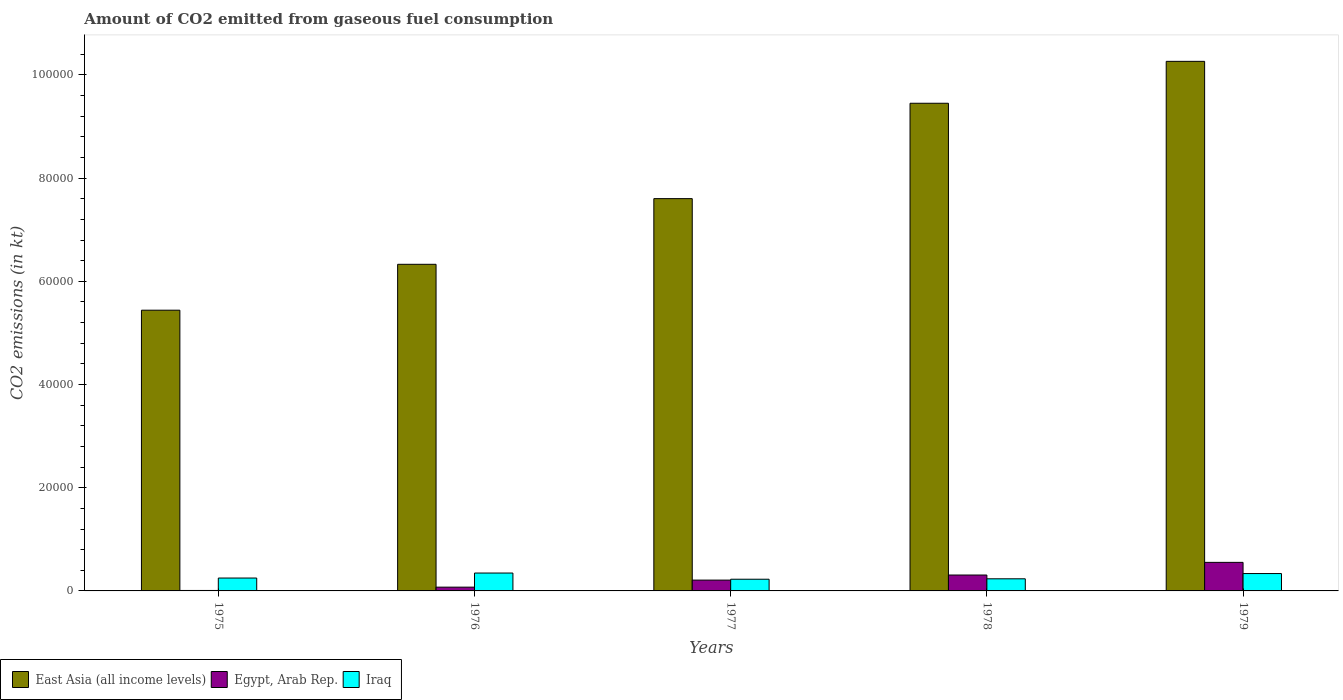Are the number of bars per tick equal to the number of legend labels?
Your response must be concise. Yes. Are the number of bars on each tick of the X-axis equal?
Provide a succinct answer. Yes. What is the label of the 1st group of bars from the left?
Your response must be concise. 1975. In how many cases, is the number of bars for a given year not equal to the number of legend labels?
Your response must be concise. 0. What is the amount of CO2 emitted in East Asia (all income levels) in 1976?
Ensure brevity in your answer.  6.33e+04. Across all years, what is the maximum amount of CO2 emitted in East Asia (all income levels)?
Provide a succinct answer. 1.03e+05. Across all years, what is the minimum amount of CO2 emitted in Egypt, Arab Rep.?
Your answer should be very brief. 88.01. In which year was the amount of CO2 emitted in Iraq maximum?
Your answer should be very brief. 1976. In which year was the amount of CO2 emitted in East Asia (all income levels) minimum?
Give a very brief answer. 1975. What is the total amount of CO2 emitted in East Asia (all income levels) in the graph?
Give a very brief answer. 3.91e+05. What is the difference between the amount of CO2 emitted in East Asia (all income levels) in 1976 and that in 1977?
Your answer should be very brief. -1.27e+04. What is the difference between the amount of CO2 emitted in Iraq in 1977 and the amount of CO2 emitted in East Asia (all income levels) in 1976?
Provide a succinct answer. -6.10e+04. What is the average amount of CO2 emitted in Egypt, Arab Rep. per year?
Keep it short and to the point. 2305.81. In the year 1977, what is the difference between the amount of CO2 emitted in Iraq and amount of CO2 emitted in East Asia (all income levels)?
Your answer should be very brief. -7.38e+04. What is the ratio of the amount of CO2 emitted in East Asia (all income levels) in 1975 to that in 1976?
Offer a very short reply. 0.86. Is the amount of CO2 emitted in Egypt, Arab Rep. in 1976 less than that in 1977?
Offer a very short reply. Yes. Is the difference between the amount of CO2 emitted in Iraq in 1975 and 1978 greater than the difference between the amount of CO2 emitted in East Asia (all income levels) in 1975 and 1978?
Provide a succinct answer. Yes. What is the difference between the highest and the second highest amount of CO2 emitted in Egypt, Arab Rep.?
Your answer should be very brief. 2453.22. What is the difference between the highest and the lowest amount of CO2 emitted in East Asia (all income levels)?
Your answer should be very brief. 4.82e+04. Is the sum of the amount of CO2 emitted in East Asia (all income levels) in 1975 and 1978 greater than the maximum amount of CO2 emitted in Egypt, Arab Rep. across all years?
Your response must be concise. Yes. What does the 3rd bar from the left in 1975 represents?
Offer a terse response. Iraq. What does the 2nd bar from the right in 1978 represents?
Give a very brief answer. Egypt, Arab Rep. Are the values on the major ticks of Y-axis written in scientific E-notation?
Provide a succinct answer. No. Does the graph contain any zero values?
Keep it short and to the point. No. Does the graph contain grids?
Provide a short and direct response. No. How many legend labels are there?
Make the answer very short. 3. What is the title of the graph?
Your answer should be very brief. Amount of CO2 emitted from gaseous fuel consumption. What is the label or title of the X-axis?
Ensure brevity in your answer.  Years. What is the label or title of the Y-axis?
Give a very brief answer. CO2 emissions (in kt). What is the CO2 emissions (in kt) in East Asia (all income levels) in 1975?
Offer a very short reply. 5.44e+04. What is the CO2 emissions (in kt) in Egypt, Arab Rep. in 1975?
Your response must be concise. 88.01. What is the CO2 emissions (in kt) in Iraq in 1975?
Offer a very short reply. 2497.23. What is the CO2 emissions (in kt) in East Asia (all income levels) in 1976?
Your answer should be very brief. 6.33e+04. What is the CO2 emissions (in kt) in Egypt, Arab Rep. in 1976?
Offer a terse response. 729.73. What is the CO2 emissions (in kt) of Iraq in 1976?
Keep it short and to the point. 3465.32. What is the CO2 emissions (in kt) in East Asia (all income levels) in 1977?
Your answer should be compact. 7.60e+04. What is the CO2 emissions (in kt) of Egypt, Arab Rep. in 1977?
Provide a short and direct response. 2097.52. What is the CO2 emissions (in kt) in Iraq in 1977?
Provide a succinct answer. 2266.21. What is the CO2 emissions (in kt) in East Asia (all income levels) in 1978?
Give a very brief answer. 9.45e+04. What is the CO2 emissions (in kt) of Egypt, Arab Rep. in 1978?
Offer a terse response. 3080.28. What is the CO2 emissions (in kt) of Iraq in 1978?
Offer a very short reply. 2346.88. What is the CO2 emissions (in kt) in East Asia (all income levels) in 1979?
Your response must be concise. 1.03e+05. What is the CO2 emissions (in kt) in Egypt, Arab Rep. in 1979?
Your response must be concise. 5533.5. What is the CO2 emissions (in kt) of Iraq in 1979?
Ensure brevity in your answer.  3366.31. Across all years, what is the maximum CO2 emissions (in kt) in East Asia (all income levels)?
Your answer should be compact. 1.03e+05. Across all years, what is the maximum CO2 emissions (in kt) of Egypt, Arab Rep.?
Provide a succinct answer. 5533.5. Across all years, what is the maximum CO2 emissions (in kt) of Iraq?
Your response must be concise. 3465.32. Across all years, what is the minimum CO2 emissions (in kt) in East Asia (all income levels)?
Provide a short and direct response. 5.44e+04. Across all years, what is the minimum CO2 emissions (in kt) in Egypt, Arab Rep.?
Provide a short and direct response. 88.01. Across all years, what is the minimum CO2 emissions (in kt) of Iraq?
Keep it short and to the point. 2266.21. What is the total CO2 emissions (in kt) of East Asia (all income levels) in the graph?
Offer a terse response. 3.91e+05. What is the total CO2 emissions (in kt) of Egypt, Arab Rep. in the graph?
Ensure brevity in your answer.  1.15e+04. What is the total CO2 emissions (in kt) in Iraq in the graph?
Your response must be concise. 1.39e+04. What is the difference between the CO2 emissions (in kt) of East Asia (all income levels) in 1975 and that in 1976?
Offer a very short reply. -8892.04. What is the difference between the CO2 emissions (in kt) of Egypt, Arab Rep. in 1975 and that in 1976?
Your answer should be very brief. -641.73. What is the difference between the CO2 emissions (in kt) in Iraq in 1975 and that in 1976?
Your response must be concise. -968.09. What is the difference between the CO2 emissions (in kt) of East Asia (all income levels) in 1975 and that in 1977?
Provide a succinct answer. -2.16e+04. What is the difference between the CO2 emissions (in kt) of Egypt, Arab Rep. in 1975 and that in 1977?
Provide a succinct answer. -2009.52. What is the difference between the CO2 emissions (in kt) of Iraq in 1975 and that in 1977?
Offer a very short reply. 231.02. What is the difference between the CO2 emissions (in kt) of East Asia (all income levels) in 1975 and that in 1978?
Your answer should be compact. -4.01e+04. What is the difference between the CO2 emissions (in kt) in Egypt, Arab Rep. in 1975 and that in 1978?
Offer a very short reply. -2992.27. What is the difference between the CO2 emissions (in kt) of Iraq in 1975 and that in 1978?
Your response must be concise. 150.35. What is the difference between the CO2 emissions (in kt) in East Asia (all income levels) in 1975 and that in 1979?
Give a very brief answer. -4.82e+04. What is the difference between the CO2 emissions (in kt) of Egypt, Arab Rep. in 1975 and that in 1979?
Make the answer very short. -5445.49. What is the difference between the CO2 emissions (in kt) in Iraq in 1975 and that in 1979?
Ensure brevity in your answer.  -869.08. What is the difference between the CO2 emissions (in kt) in East Asia (all income levels) in 1976 and that in 1977?
Ensure brevity in your answer.  -1.27e+04. What is the difference between the CO2 emissions (in kt) of Egypt, Arab Rep. in 1976 and that in 1977?
Your answer should be compact. -1367.79. What is the difference between the CO2 emissions (in kt) of Iraq in 1976 and that in 1977?
Provide a succinct answer. 1199.11. What is the difference between the CO2 emissions (in kt) of East Asia (all income levels) in 1976 and that in 1978?
Ensure brevity in your answer.  -3.12e+04. What is the difference between the CO2 emissions (in kt) in Egypt, Arab Rep. in 1976 and that in 1978?
Make the answer very short. -2350.55. What is the difference between the CO2 emissions (in kt) in Iraq in 1976 and that in 1978?
Provide a short and direct response. 1118.43. What is the difference between the CO2 emissions (in kt) in East Asia (all income levels) in 1976 and that in 1979?
Ensure brevity in your answer.  -3.93e+04. What is the difference between the CO2 emissions (in kt) in Egypt, Arab Rep. in 1976 and that in 1979?
Make the answer very short. -4803.77. What is the difference between the CO2 emissions (in kt) in Iraq in 1976 and that in 1979?
Offer a terse response. 99.01. What is the difference between the CO2 emissions (in kt) in East Asia (all income levels) in 1977 and that in 1978?
Make the answer very short. -1.85e+04. What is the difference between the CO2 emissions (in kt) in Egypt, Arab Rep. in 1977 and that in 1978?
Make the answer very short. -982.76. What is the difference between the CO2 emissions (in kt) of Iraq in 1977 and that in 1978?
Ensure brevity in your answer.  -80.67. What is the difference between the CO2 emissions (in kt) of East Asia (all income levels) in 1977 and that in 1979?
Offer a terse response. -2.66e+04. What is the difference between the CO2 emissions (in kt) of Egypt, Arab Rep. in 1977 and that in 1979?
Your answer should be compact. -3435.98. What is the difference between the CO2 emissions (in kt) in Iraq in 1977 and that in 1979?
Provide a short and direct response. -1100.1. What is the difference between the CO2 emissions (in kt) of East Asia (all income levels) in 1978 and that in 1979?
Give a very brief answer. -8120.28. What is the difference between the CO2 emissions (in kt) of Egypt, Arab Rep. in 1978 and that in 1979?
Provide a short and direct response. -2453.22. What is the difference between the CO2 emissions (in kt) of Iraq in 1978 and that in 1979?
Offer a very short reply. -1019.43. What is the difference between the CO2 emissions (in kt) of East Asia (all income levels) in 1975 and the CO2 emissions (in kt) of Egypt, Arab Rep. in 1976?
Ensure brevity in your answer.  5.37e+04. What is the difference between the CO2 emissions (in kt) in East Asia (all income levels) in 1975 and the CO2 emissions (in kt) in Iraq in 1976?
Ensure brevity in your answer.  5.09e+04. What is the difference between the CO2 emissions (in kt) in Egypt, Arab Rep. in 1975 and the CO2 emissions (in kt) in Iraq in 1976?
Keep it short and to the point. -3377.31. What is the difference between the CO2 emissions (in kt) in East Asia (all income levels) in 1975 and the CO2 emissions (in kt) in Egypt, Arab Rep. in 1977?
Ensure brevity in your answer.  5.23e+04. What is the difference between the CO2 emissions (in kt) of East Asia (all income levels) in 1975 and the CO2 emissions (in kt) of Iraq in 1977?
Offer a terse response. 5.21e+04. What is the difference between the CO2 emissions (in kt) of Egypt, Arab Rep. in 1975 and the CO2 emissions (in kt) of Iraq in 1977?
Your answer should be compact. -2178.2. What is the difference between the CO2 emissions (in kt) in East Asia (all income levels) in 1975 and the CO2 emissions (in kt) in Egypt, Arab Rep. in 1978?
Give a very brief answer. 5.13e+04. What is the difference between the CO2 emissions (in kt) of East Asia (all income levels) in 1975 and the CO2 emissions (in kt) of Iraq in 1978?
Your answer should be very brief. 5.21e+04. What is the difference between the CO2 emissions (in kt) in Egypt, Arab Rep. in 1975 and the CO2 emissions (in kt) in Iraq in 1978?
Your response must be concise. -2258.87. What is the difference between the CO2 emissions (in kt) in East Asia (all income levels) in 1975 and the CO2 emissions (in kt) in Egypt, Arab Rep. in 1979?
Your answer should be compact. 4.89e+04. What is the difference between the CO2 emissions (in kt) of East Asia (all income levels) in 1975 and the CO2 emissions (in kt) of Iraq in 1979?
Offer a very short reply. 5.10e+04. What is the difference between the CO2 emissions (in kt) of Egypt, Arab Rep. in 1975 and the CO2 emissions (in kt) of Iraq in 1979?
Ensure brevity in your answer.  -3278.3. What is the difference between the CO2 emissions (in kt) in East Asia (all income levels) in 1976 and the CO2 emissions (in kt) in Egypt, Arab Rep. in 1977?
Provide a succinct answer. 6.12e+04. What is the difference between the CO2 emissions (in kt) in East Asia (all income levels) in 1976 and the CO2 emissions (in kt) in Iraq in 1977?
Offer a terse response. 6.10e+04. What is the difference between the CO2 emissions (in kt) of Egypt, Arab Rep. in 1976 and the CO2 emissions (in kt) of Iraq in 1977?
Provide a short and direct response. -1536.47. What is the difference between the CO2 emissions (in kt) in East Asia (all income levels) in 1976 and the CO2 emissions (in kt) in Egypt, Arab Rep. in 1978?
Make the answer very short. 6.02e+04. What is the difference between the CO2 emissions (in kt) in East Asia (all income levels) in 1976 and the CO2 emissions (in kt) in Iraq in 1978?
Provide a short and direct response. 6.10e+04. What is the difference between the CO2 emissions (in kt) in Egypt, Arab Rep. in 1976 and the CO2 emissions (in kt) in Iraq in 1978?
Keep it short and to the point. -1617.15. What is the difference between the CO2 emissions (in kt) of East Asia (all income levels) in 1976 and the CO2 emissions (in kt) of Egypt, Arab Rep. in 1979?
Provide a short and direct response. 5.78e+04. What is the difference between the CO2 emissions (in kt) in East Asia (all income levels) in 1976 and the CO2 emissions (in kt) in Iraq in 1979?
Provide a succinct answer. 5.99e+04. What is the difference between the CO2 emissions (in kt) in Egypt, Arab Rep. in 1976 and the CO2 emissions (in kt) in Iraq in 1979?
Provide a short and direct response. -2636.57. What is the difference between the CO2 emissions (in kt) of East Asia (all income levels) in 1977 and the CO2 emissions (in kt) of Egypt, Arab Rep. in 1978?
Offer a terse response. 7.29e+04. What is the difference between the CO2 emissions (in kt) in East Asia (all income levels) in 1977 and the CO2 emissions (in kt) in Iraq in 1978?
Your answer should be compact. 7.37e+04. What is the difference between the CO2 emissions (in kt) of Egypt, Arab Rep. in 1977 and the CO2 emissions (in kt) of Iraq in 1978?
Offer a very short reply. -249.36. What is the difference between the CO2 emissions (in kt) in East Asia (all income levels) in 1977 and the CO2 emissions (in kt) in Egypt, Arab Rep. in 1979?
Provide a succinct answer. 7.05e+04. What is the difference between the CO2 emissions (in kt) in East Asia (all income levels) in 1977 and the CO2 emissions (in kt) in Iraq in 1979?
Provide a short and direct response. 7.27e+04. What is the difference between the CO2 emissions (in kt) in Egypt, Arab Rep. in 1977 and the CO2 emissions (in kt) in Iraq in 1979?
Offer a terse response. -1268.78. What is the difference between the CO2 emissions (in kt) of East Asia (all income levels) in 1978 and the CO2 emissions (in kt) of Egypt, Arab Rep. in 1979?
Make the answer very short. 8.90e+04. What is the difference between the CO2 emissions (in kt) in East Asia (all income levels) in 1978 and the CO2 emissions (in kt) in Iraq in 1979?
Offer a very short reply. 9.11e+04. What is the difference between the CO2 emissions (in kt) in Egypt, Arab Rep. in 1978 and the CO2 emissions (in kt) in Iraq in 1979?
Give a very brief answer. -286.03. What is the average CO2 emissions (in kt) in East Asia (all income levels) per year?
Provide a short and direct response. 7.82e+04. What is the average CO2 emissions (in kt) in Egypt, Arab Rep. per year?
Offer a very short reply. 2305.81. What is the average CO2 emissions (in kt) of Iraq per year?
Your answer should be compact. 2788.39. In the year 1975, what is the difference between the CO2 emissions (in kt) in East Asia (all income levels) and CO2 emissions (in kt) in Egypt, Arab Rep.?
Your answer should be compact. 5.43e+04. In the year 1975, what is the difference between the CO2 emissions (in kt) in East Asia (all income levels) and CO2 emissions (in kt) in Iraq?
Provide a short and direct response. 5.19e+04. In the year 1975, what is the difference between the CO2 emissions (in kt) in Egypt, Arab Rep. and CO2 emissions (in kt) in Iraq?
Provide a succinct answer. -2409.22. In the year 1976, what is the difference between the CO2 emissions (in kt) in East Asia (all income levels) and CO2 emissions (in kt) in Egypt, Arab Rep.?
Provide a short and direct response. 6.26e+04. In the year 1976, what is the difference between the CO2 emissions (in kt) in East Asia (all income levels) and CO2 emissions (in kt) in Iraq?
Give a very brief answer. 5.98e+04. In the year 1976, what is the difference between the CO2 emissions (in kt) in Egypt, Arab Rep. and CO2 emissions (in kt) in Iraq?
Your response must be concise. -2735.58. In the year 1977, what is the difference between the CO2 emissions (in kt) in East Asia (all income levels) and CO2 emissions (in kt) in Egypt, Arab Rep.?
Ensure brevity in your answer.  7.39e+04. In the year 1977, what is the difference between the CO2 emissions (in kt) of East Asia (all income levels) and CO2 emissions (in kt) of Iraq?
Provide a succinct answer. 7.38e+04. In the year 1977, what is the difference between the CO2 emissions (in kt) in Egypt, Arab Rep. and CO2 emissions (in kt) in Iraq?
Offer a terse response. -168.68. In the year 1978, what is the difference between the CO2 emissions (in kt) of East Asia (all income levels) and CO2 emissions (in kt) of Egypt, Arab Rep.?
Provide a short and direct response. 9.14e+04. In the year 1978, what is the difference between the CO2 emissions (in kt) of East Asia (all income levels) and CO2 emissions (in kt) of Iraq?
Offer a very short reply. 9.22e+04. In the year 1978, what is the difference between the CO2 emissions (in kt) of Egypt, Arab Rep. and CO2 emissions (in kt) of Iraq?
Your response must be concise. 733.4. In the year 1979, what is the difference between the CO2 emissions (in kt) in East Asia (all income levels) and CO2 emissions (in kt) in Egypt, Arab Rep.?
Provide a succinct answer. 9.71e+04. In the year 1979, what is the difference between the CO2 emissions (in kt) in East Asia (all income levels) and CO2 emissions (in kt) in Iraq?
Your response must be concise. 9.93e+04. In the year 1979, what is the difference between the CO2 emissions (in kt) of Egypt, Arab Rep. and CO2 emissions (in kt) of Iraq?
Offer a very short reply. 2167.2. What is the ratio of the CO2 emissions (in kt) in East Asia (all income levels) in 1975 to that in 1976?
Keep it short and to the point. 0.86. What is the ratio of the CO2 emissions (in kt) of Egypt, Arab Rep. in 1975 to that in 1976?
Keep it short and to the point. 0.12. What is the ratio of the CO2 emissions (in kt) of Iraq in 1975 to that in 1976?
Your response must be concise. 0.72. What is the ratio of the CO2 emissions (in kt) in East Asia (all income levels) in 1975 to that in 1977?
Offer a very short reply. 0.72. What is the ratio of the CO2 emissions (in kt) of Egypt, Arab Rep. in 1975 to that in 1977?
Your answer should be compact. 0.04. What is the ratio of the CO2 emissions (in kt) of Iraq in 1975 to that in 1977?
Your answer should be very brief. 1.1. What is the ratio of the CO2 emissions (in kt) in East Asia (all income levels) in 1975 to that in 1978?
Ensure brevity in your answer.  0.58. What is the ratio of the CO2 emissions (in kt) of Egypt, Arab Rep. in 1975 to that in 1978?
Make the answer very short. 0.03. What is the ratio of the CO2 emissions (in kt) of Iraq in 1975 to that in 1978?
Make the answer very short. 1.06. What is the ratio of the CO2 emissions (in kt) of East Asia (all income levels) in 1975 to that in 1979?
Ensure brevity in your answer.  0.53. What is the ratio of the CO2 emissions (in kt) in Egypt, Arab Rep. in 1975 to that in 1979?
Keep it short and to the point. 0.02. What is the ratio of the CO2 emissions (in kt) of Iraq in 1975 to that in 1979?
Keep it short and to the point. 0.74. What is the ratio of the CO2 emissions (in kt) in East Asia (all income levels) in 1976 to that in 1977?
Provide a short and direct response. 0.83. What is the ratio of the CO2 emissions (in kt) in Egypt, Arab Rep. in 1976 to that in 1977?
Ensure brevity in your answer.  0.35. What is the ratio of the CO2 emissions (in kt) of Iraq in 1976 to that in 1977?
Offer a very short reply. 1.53. What is the ratio of the CO2 emissions (in kt) in East Asia (all income levels) in 1976 to that in 1978?
Give a very brief answer. 0.67. What is the ratio of the CO2 emissions (in kt) of Egypt, Arab Rep. in 1976 to that in 1978?
Your answer should be compact. 0.24. What is the ratio of the CO2 emissions (in kt) of Iraq in 1976 to that in 1978?
Provide a short and direct response. 1.48. What is the ratio of the CO2 emissions (in kt) in East Asia (all income levels) in 1976 to that in 1979?
Your response must be concise. 0.62. What is the ratio of the CO2 emissions (in kt) in Egypt, Arab Rep. in 1976 to that in 1979?
Your response must be concise. 0.13. What is the ratio of the CO2 emissions (in kt) of Iraq in 1976 to that in 1979?
Ensure brevity in your answer.  1.03. What is the ratio of the CO2 emissions (in kt) in East Asia (all income levels) in 1977 to that in 1978?
Provide a succinct answer. 0.8. What is the ratio of the CO2 emissions (in kt) of Egypt, Arab Rep. in 1977 to that in 1978?
Provide a short and direct response. 0.68. What is the ratio of the CO2 emissions (in kt) of Iraq in 1977 to that in 1978?
Your answer should be very brief. 0.97. What is the ratio of the CO2 emissions (in kt) in East Asia (all income levels) in 1977 to that in 1979?
Provide a succinct answer. 0.74. What is the ratio of the CO2 emissions (in kt) of Egypt, Arab Rep. in 1977 to that in 1979?
Offer a terse response. 0.38. What is the ratio of the CO2 emissions (in kt) in Iraq in 1977 to that in 1979?
Your response must be concise. 0.67. What is the ratio of the CO2 emissions (in kt) of East Asia (all income levels) in 1978 to that in 1979?
Your response must be concise. 0.92. What is the ratio of the CO2 emissions (in kt) of Egypt, Arab Rep. in 1978 to that in 1979?
Give a very brief answer. 0.56. What is the ratio of the CO2 emissions (in kt) in Iraq in 1978 to that in 1979?
Your answer should be very brief. 0.7. What is the difference between the highest and the second highest CO2 emissions (in kt) of East Asia (all income levels)?
Offer a terse response. 8120.28. What is the difference between the highest and the second highest CO2 emissions (in kt) of Egypt, Arab Rep.?
Your answer should be very brief. 2453.22. What is the difference between the highest and the second highest CO2 emissions (in kt) of Iraq?
Give a very brief answer. 99.01. What is the difference between the highest and the lowest CO2 emissions (in kt) in East Asia (all income levels)?
Provide a succinct answer. 4.82e+04. What is the difference between the highest and the lowest CO2 emissions (in kt) of Egypt, Arab Rep.?
Offer a terse response. 5445.49. What is the difference between the highest and the lowest CO2 emissions (in kt) in Iraq?
Offer a terse response. 1199.11. 